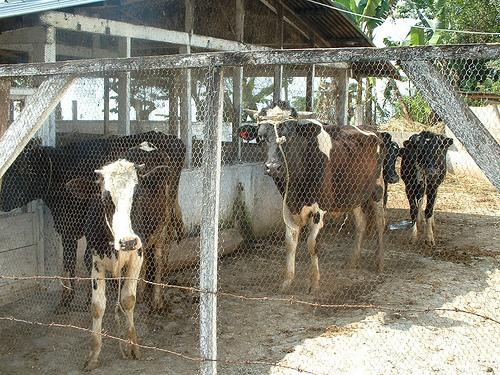The nearby cow to the left who is looking at the camera wears what color down his face? white 